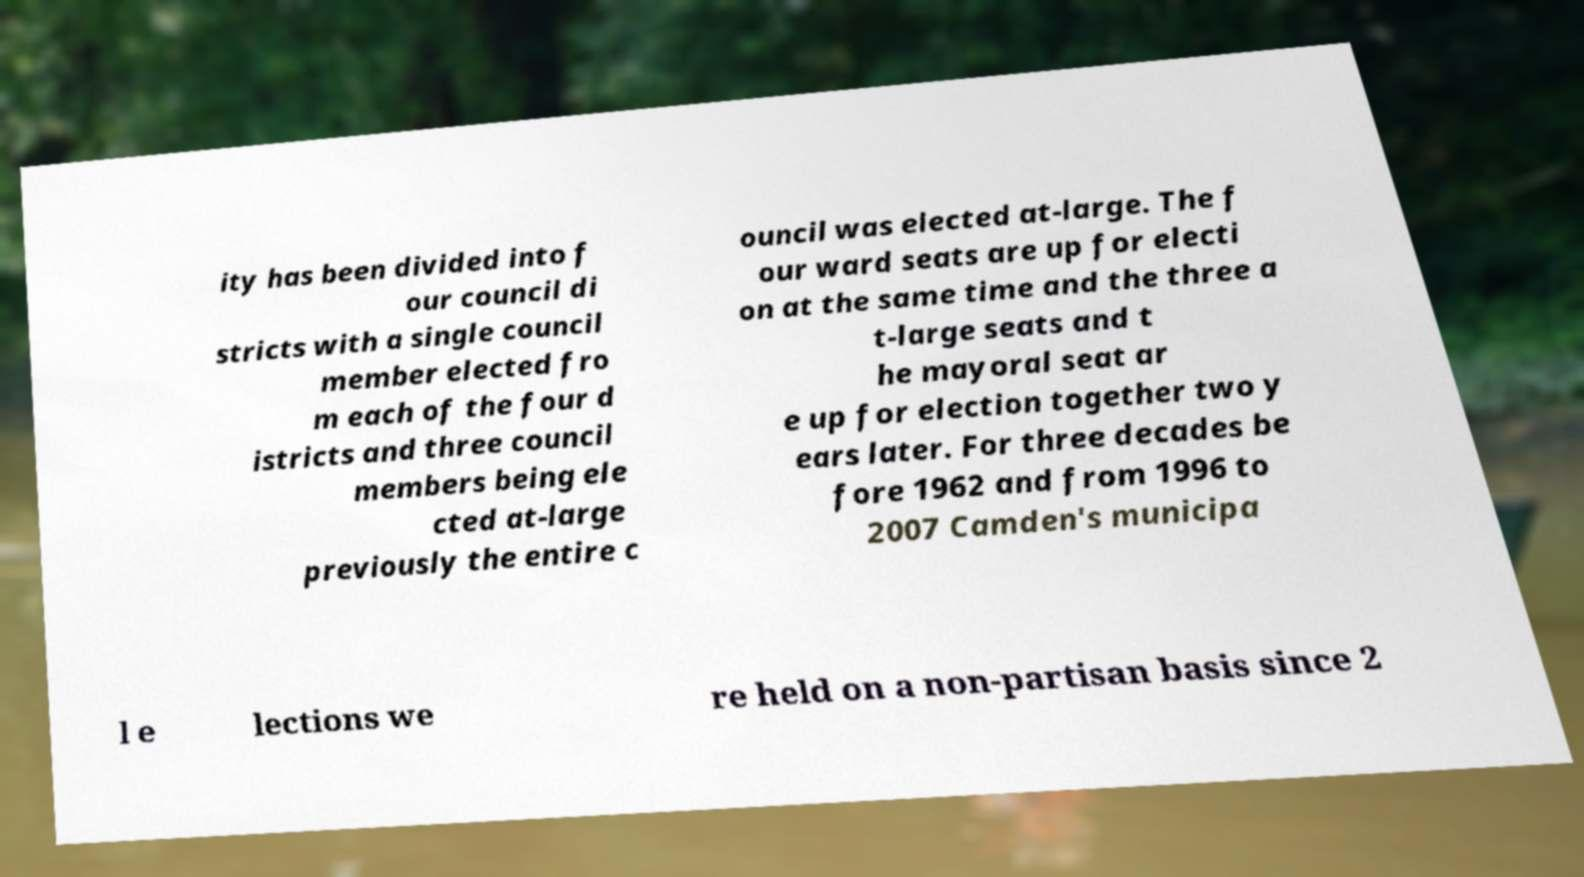Could you assist in decoding the text presented in this image and type it out clearly? ity has been divided into f our council di stricts with a single council member elected fro m each of the four d istricts and three council members being ele cted at-large previously the entire c ouncil was elected at-large. The f our ward seats are up for electi on at the same time and the three a t-large seats and t he mayoral seat ar e up for election together two y ears later. For three decades be fore 1962 and from 1996 to 2007 Camden's municipa l e lections we re held on a non-partisan basis since 2 